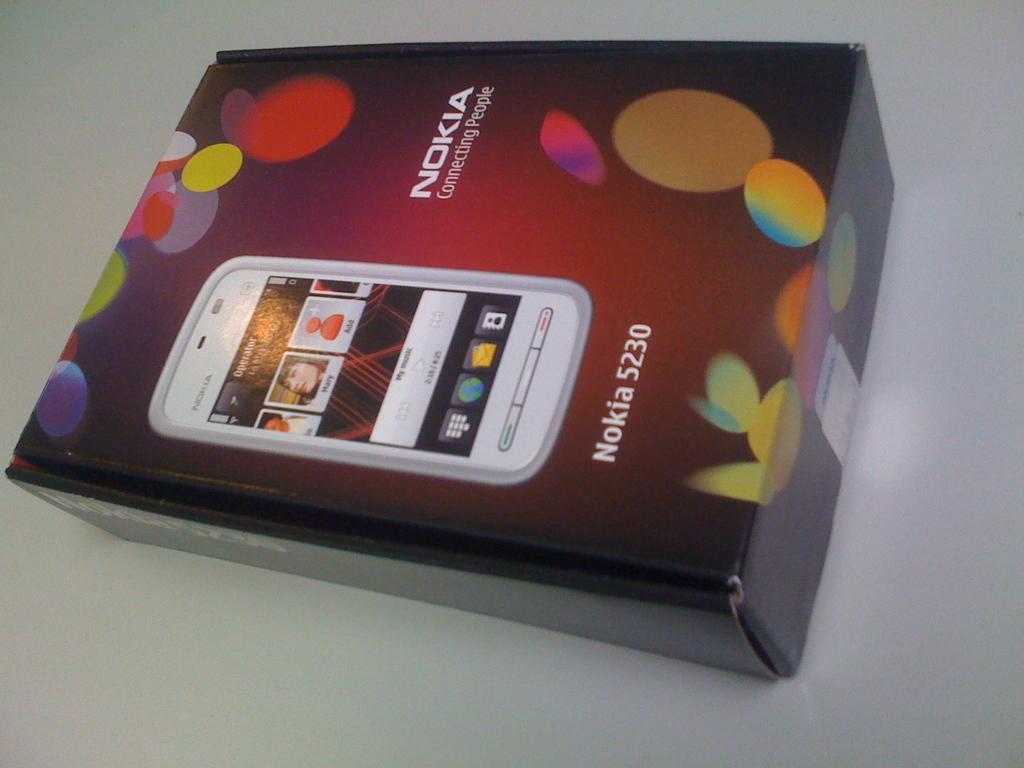Can you describe this image briefly? In the image we can see a box on a table. 